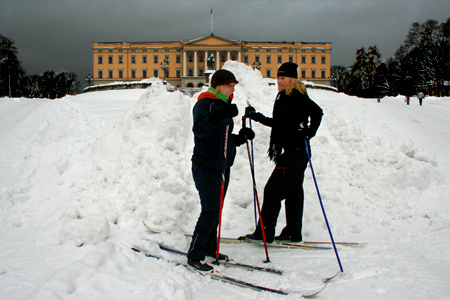Who is in front of the building? The girl is in front of the building. 